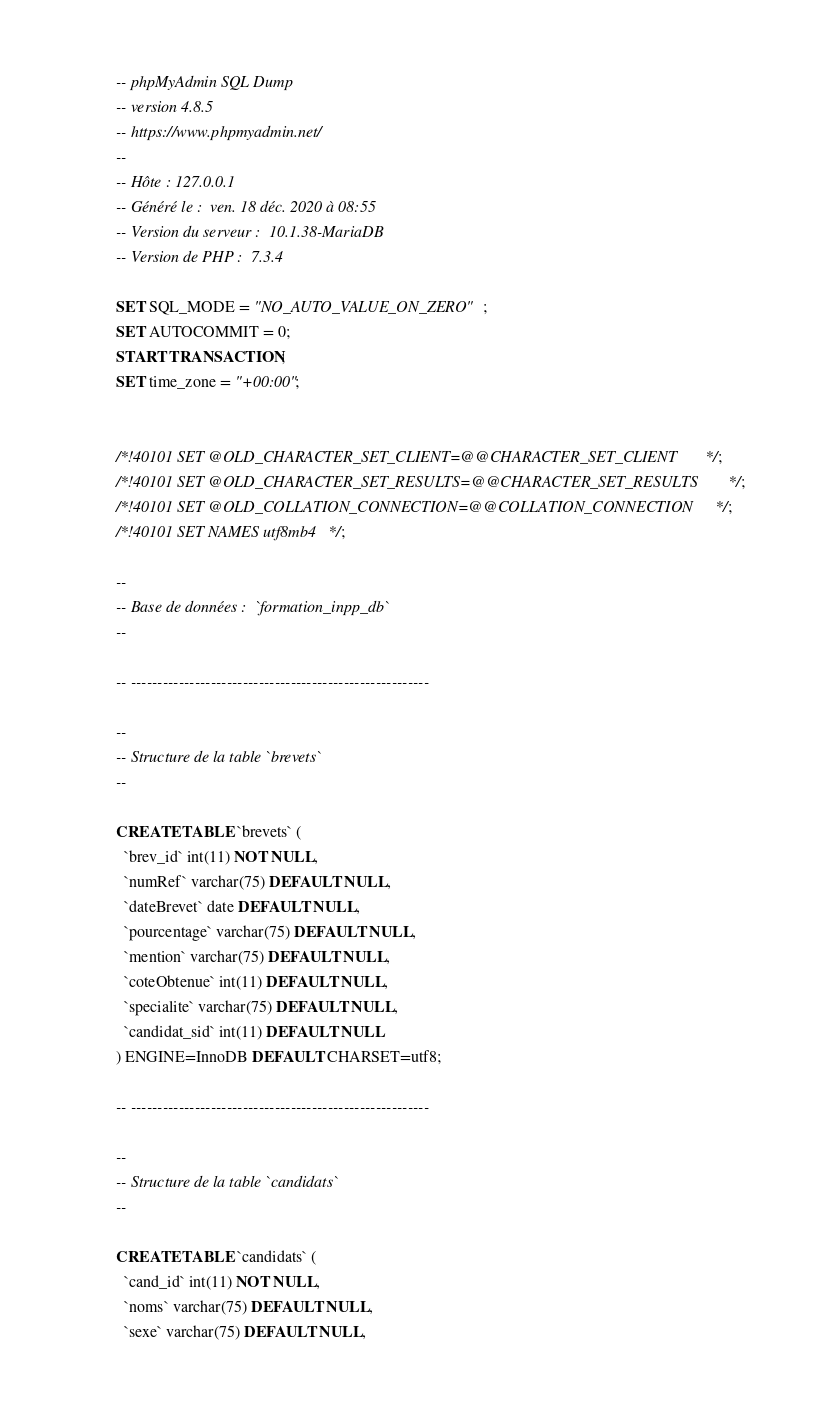Convert code to text. <code><loc_0><loc_0><loc_500><loc_500><_SQL_>-- phpMyAdmin SQL Dump
-- version 4.8.5
-- https://www.phpmyadmin.net/
--
-- Hôte : 127.0.0.1
-- Généré le :  ven. 18 déc. 2020 à 08:55
-- Version du serveur :  10.1.38-MariaDB
-- Version de PHP :  7.3.4

SET SQL_MODE = "NO_AUTO_VALUE_ON_ZERO";
SET AUTOCOMMIT = 0;
START TRANSACTION;
SET time_zone = "+00:00";


/*!40101 SET @OLD_CHARACTER_SET_CLIENT=@@CHARACTER_SET_CLIENT */;
/*!40101 SET @OLD_CHARACTER_SET_RESULTS=@@CHARACTER_SET_RESULTS */;
/*!40101 SET @OLD_COLLATION_CONNECTION=@@COLLATION_CONNECTION */;
/*!40101 SET NAMES utf8mb4 */;

--
-- Base de données :  `formation_inpp_db`
--

-- --------------------------------------------------------

--
-- Structure de la table `brevets`
--

CREATE TABLE `brevets` (
  `brev_id` int(11) NOT NULL,
  `numRef` varchar(75) DEFAULT NULL,
  `dateBrevet` date DEFAULT NULL,
  `pourcentage` varchar(75) DEFAULT NULL,
  `mention` varchar(75) DEFAULT NULL,
  `coteObtenue` int(11) DEFAULT NULL,
  `specialite` varchar(75) DEFAULT NULL,
  `candidat_sid` int(11) DEFAULT NULL
) ENGINE=InnoDB DEFAULT CHARSET=utf8;

-- --------------------------------------------------------

--
-- Structure de la table `candidats`
--

CREATE TABLE `candidats` (
  `cand_id` int(11) NOT NULL,
  `noms` varchar(75) DEFAULT NULL,
  `sexe` varchar(75) DEFAULT NULL,</code> 